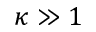Convert formula to latex. <formula><loc_0><loc_0><loc_500><loc_500>\kappa \gg 1</formula> 